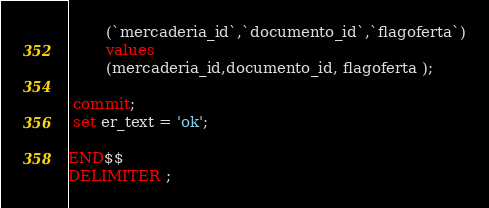Convert code to text. <code><loc_0><loc_0><loc_500><loc_500><_SQL_>		(`mercaderia_id`,`documento_id`,`flagoferta`)
		values
		(mercaderia_id,documento_id, flagoferta );

 commit; 
 set er_text = 'ok';
 
END$$
DELIMITER ;
</code> 